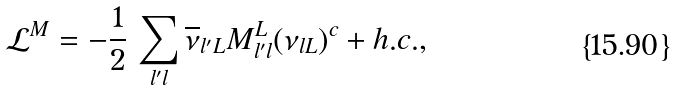Convert formula to latex. <formula><loc_0><loc_0><loc_500><loc_500>\mathcal { L } ^ { M } = - \frac { 1 } { 2 } \, \sum _ { l ^ { \prime } l } \overline { \nu } _ { l ^ { \prime } L } M ^ { L } _ { l ^ { \prime } l } ( \nu _ { l L } ) ^ { c } + h . c . ,</formula> 